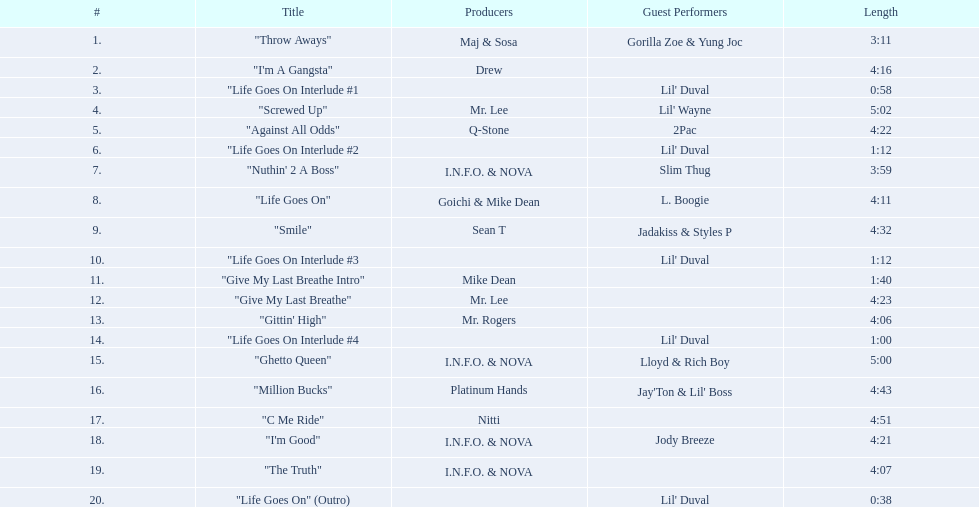What songs are featured on the album life goes on (trae album)? "Throw Aways", "I'm A Gangsta", "Life Goes On Interlude #1, "Screwed Up", "Against All Odds", "Life Goes On Interlude #2, "Nuthin' 2 A Boss", "Life Goes On", "Smile", "Life Goes On Interlude #3, "Give My Last Breathe Intro", "Give My Last Breathe", "Gittin' High", "Life Goes On Interlude #4, "Ghetto Queen", "Million Bucks", "C Me Ride", "I'm Good", "The Truth", "Life Goes On" (Outro). Which of these tracks have a duration of at least 5 minutes? "Screwed Up", "Ghetto Queen". Among these two tracks exceeding 5 minutes, which one has a greater length? "Screwed Up". What is the length of this particular song? 5:02. 